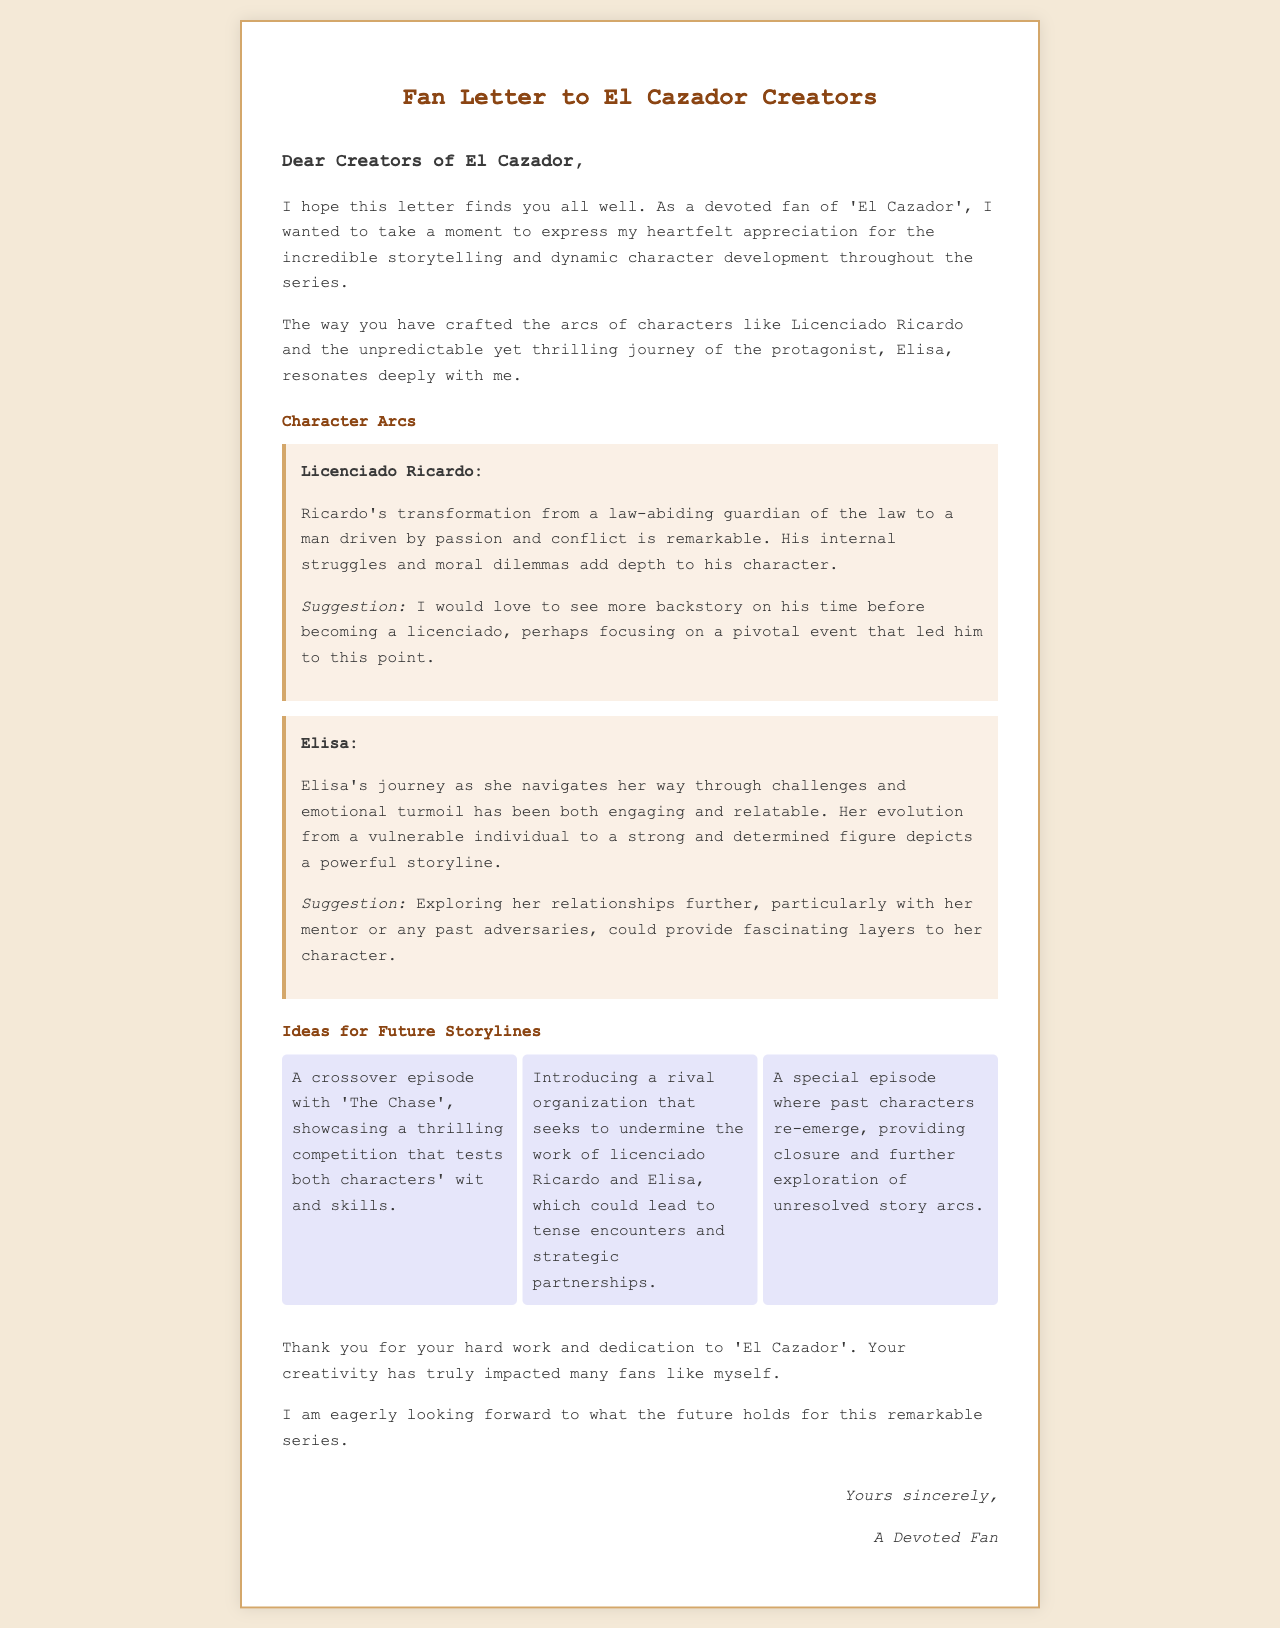What is the title of the letter? The title of the letter is prominently displayed at the top, stating its purpose.
Answer: Fan Letter to El Cazador Creators Who is the recipient of the letter? The letter begins with a direct salutation, indicating who it is addressed to.
Answer: Creators of El Cazador Which two characters' arcs are discussed in the letter? The letter specifically mentions the character arcs of two individuals, highlighting key aspects of their journeys.
Answer: Licenciado Ricardo and Elisa What is one suggestion for Licenciado Ricardo's character? The letter includes a suggestion regarding Ricardo's backstory and a notable event from his past.
Answer: More backstory on his time before becoming a licenciado What future storyline idea involves a crossover? The letter presents an idea for a storyline involving another show that could create an exciting narrative connection.
Answer: A crossover episode with 'The Chase' How many ideas for future storylines are provided? The document lists a total of specific ideas for future episodes, showing a range of creative possibilities.
Answer: Three What emotion does the fan express towards the creators? The fan's feelings are conveyed through their appreciation and admiration for the series.
Answer: Heartfelt appreciation What is the closing statement of the letter? The closing of the letter provides a wrap-up and final sentiments from the fan to the creators.
Answer: Yours sincerely 